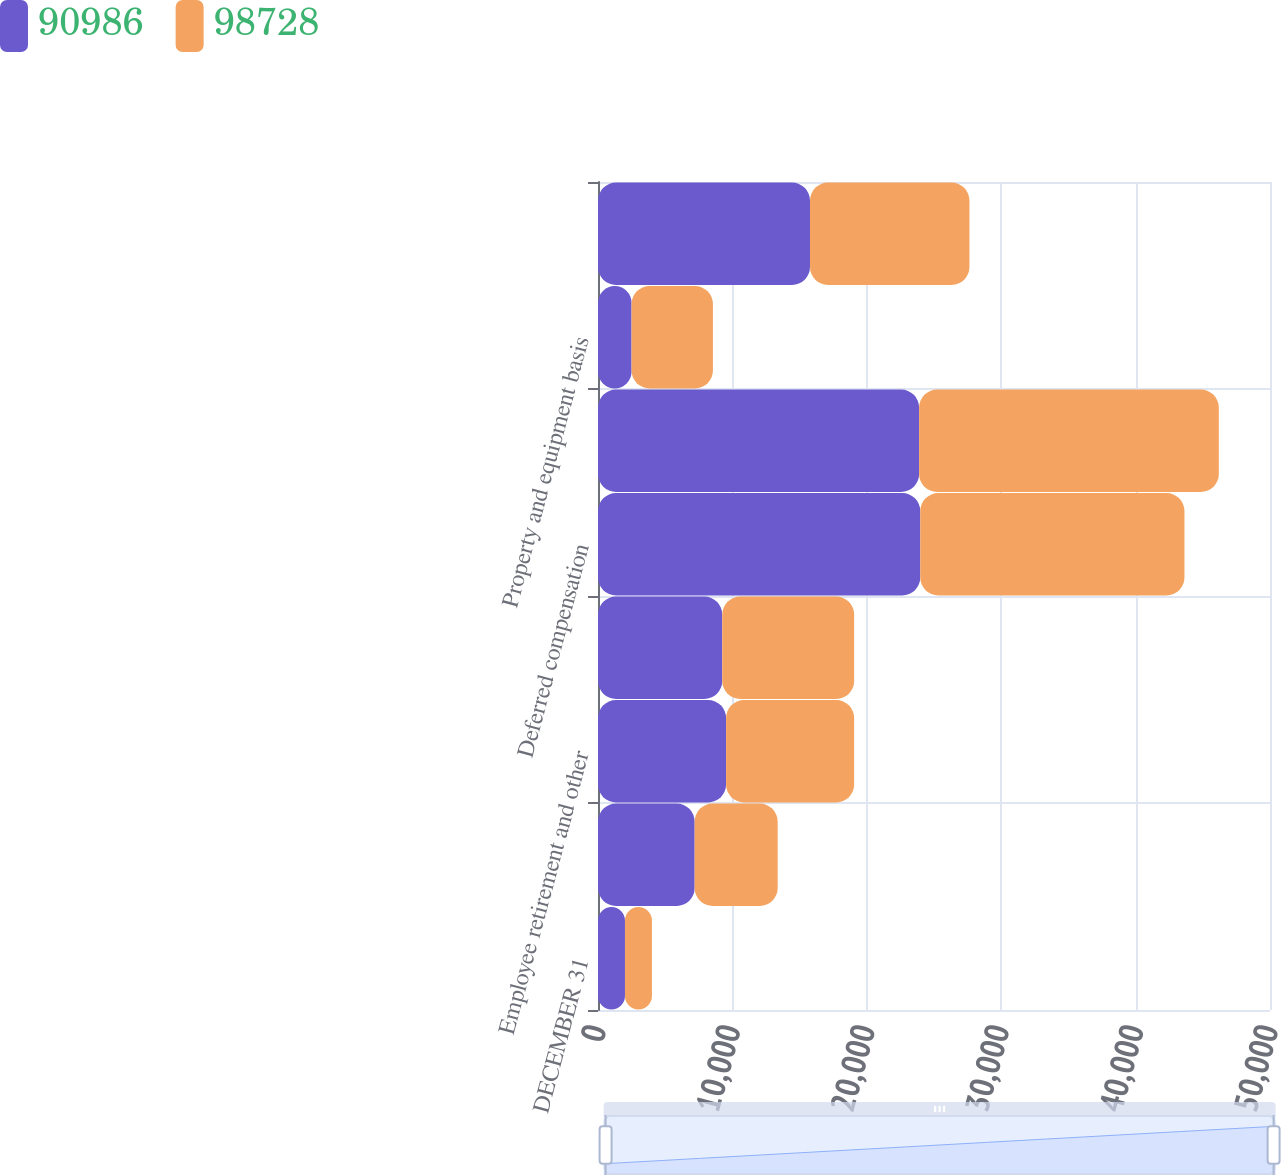Convert chart. <chart><loc_0><loc_0><loc_500><loc_500><stacked_bar_chart><ecel><fcel>DECEMBER 31<fcel>Provision for bad debts<fcel>Employee retirement and other<fcel>Workers' compensation<fcel>Deferred compensation<fcel>Credits and net operating loss<fcel>Property and equipment basis<fcel>Other<nl><fcel>90986<fcel>2007<fcel>7191<fcel>9529.5<fcel>9245<fcel>23979<fcel>23892<fcel>2497<fcel>15773<nl><fcel>98728<fcel>2006<fcel>6178<fcel>9529.5<fcel>9814<fcel>19656<fcel>22300<fcel>6054<fcel>11866<nl></chart> 